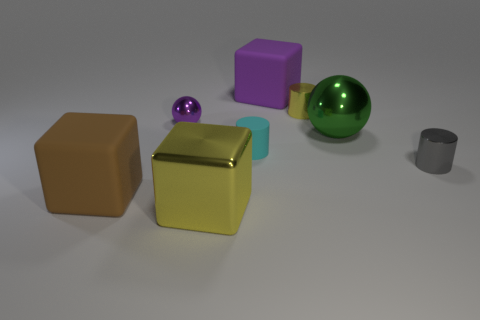Subtract all gray metallic cylinders. How many cylinders are left? 2 Add 2 green shiny things. How many objects exist? 10 Subtract all cyan cylinders. How many cylinders are left? 2 Subtract 3 blocks. How many blocks are left? 0 Subtract all cubes. How many objects are left? 5 Subtract all matte cubes. Subtract all large purple rubber things. How many objects are left? 5 Add 3 big brown rubber cubes. How many big brown rubber cubes are left? 4 Add 3 large yellow cubes. How many large yellow cubes exist? 4 Subtract 0 cyan cubes. How many objects are left? 8 Subtract all red cylinders. Subtract all cyan balls. How many cylinders are left? 3 